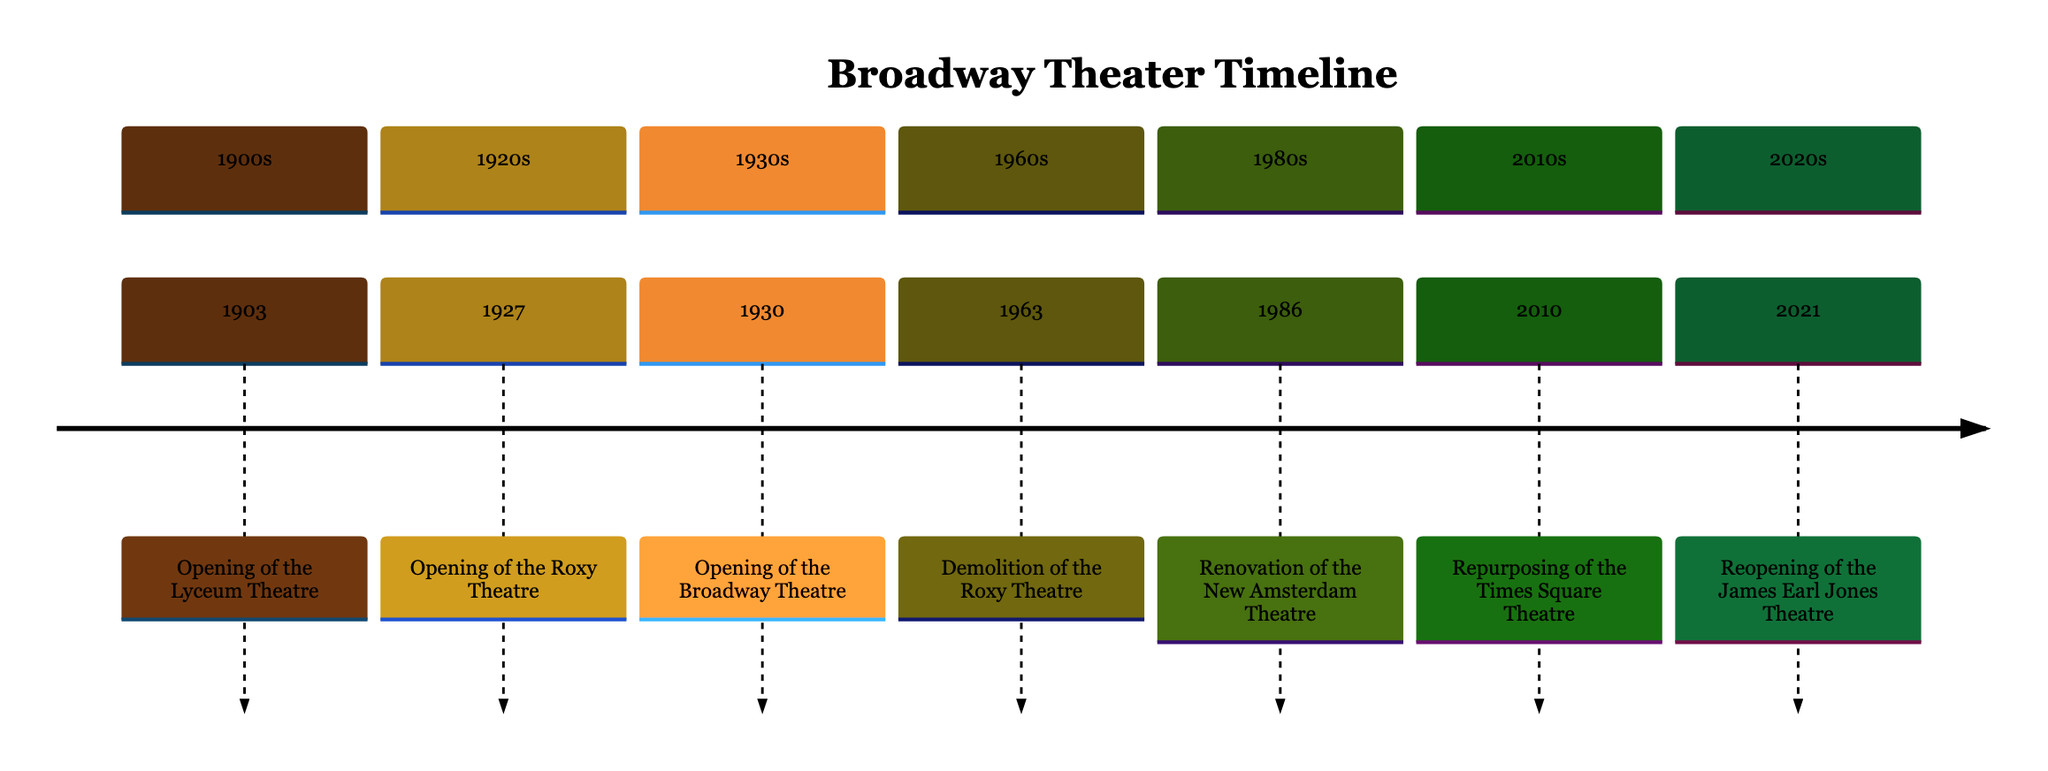What year did the Lyceum Theatre open? The Lyceum Theatre is the first event listed in the diagram, with the year clearly stated as 1903.
Answer: 1903 Which theater was demolished in 1963? The diagram specifies that the Roxy Theatre was demolished in 1963, indicated by the event listed under that year.
Answer: Roxy Theatre How many theaters are listed in the timeline? By counting each unique theater mentioned in the timeline events, there are six theaters: Lyceum, Roxy, Broadway, New Amsterdam, Times Square, and James Earl Jones.
Answer: 6 What significant renovation occurred in 1986? The event under 1986 mentions the renovation of the New Amsterdam Theatre, indicating the specific theater and year of renovation.
Answer: New Amsterdam Theatre Which theater underwent repurposing in 2010? The timeline explicitly states that the Times Square Theatre underwent significant redevelopment in 2010, indicating the change in purpose for that theater.
Answer: Times Square Theatre What was the original name of the James Earl Jones Theatre? The diagram states that it was previously named the Cort Theatre before the major renovation and subsequent renaming in 2021.
Answer: Cort Theatre In which decade did the Roxy Theatre open? The Roxy Theatre's opening year, 1927, falls within the 1920s, which is specified in the timeline section labeling.
Answer: 1920s What major event happened in 2021? According to the final event listed in the timeline, the James Earl Jones Theatre was reopened in 2021 after a major renovation.
Answer: Reopening of the James Earl Jones Theatre 